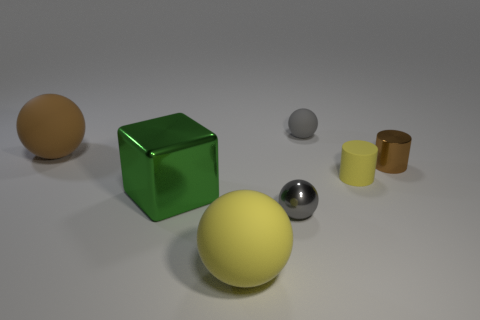Subtract all yellow spheres. How many spheres are left? 3 Subtract all cylinders. How many objects are left? 5 Add 2 cylinders. How many objects exist? 9 Subtract all brown balls. How many balls are left? 3 Subtract 1 cylinders. How many cylinders are left? 1 Subtract all gray cubes. How many red balls are left? 0 Subtract all brown cylinders. Subtract all tiny gray rubber things. How many objects are left? 5 Add 5 small yellow cylinders. How many small yellow cylinders are left? 6 Add 4 brown things. How many brown things exist? 6 Subtract 0 yellow cubes. How many objects are left? 7 